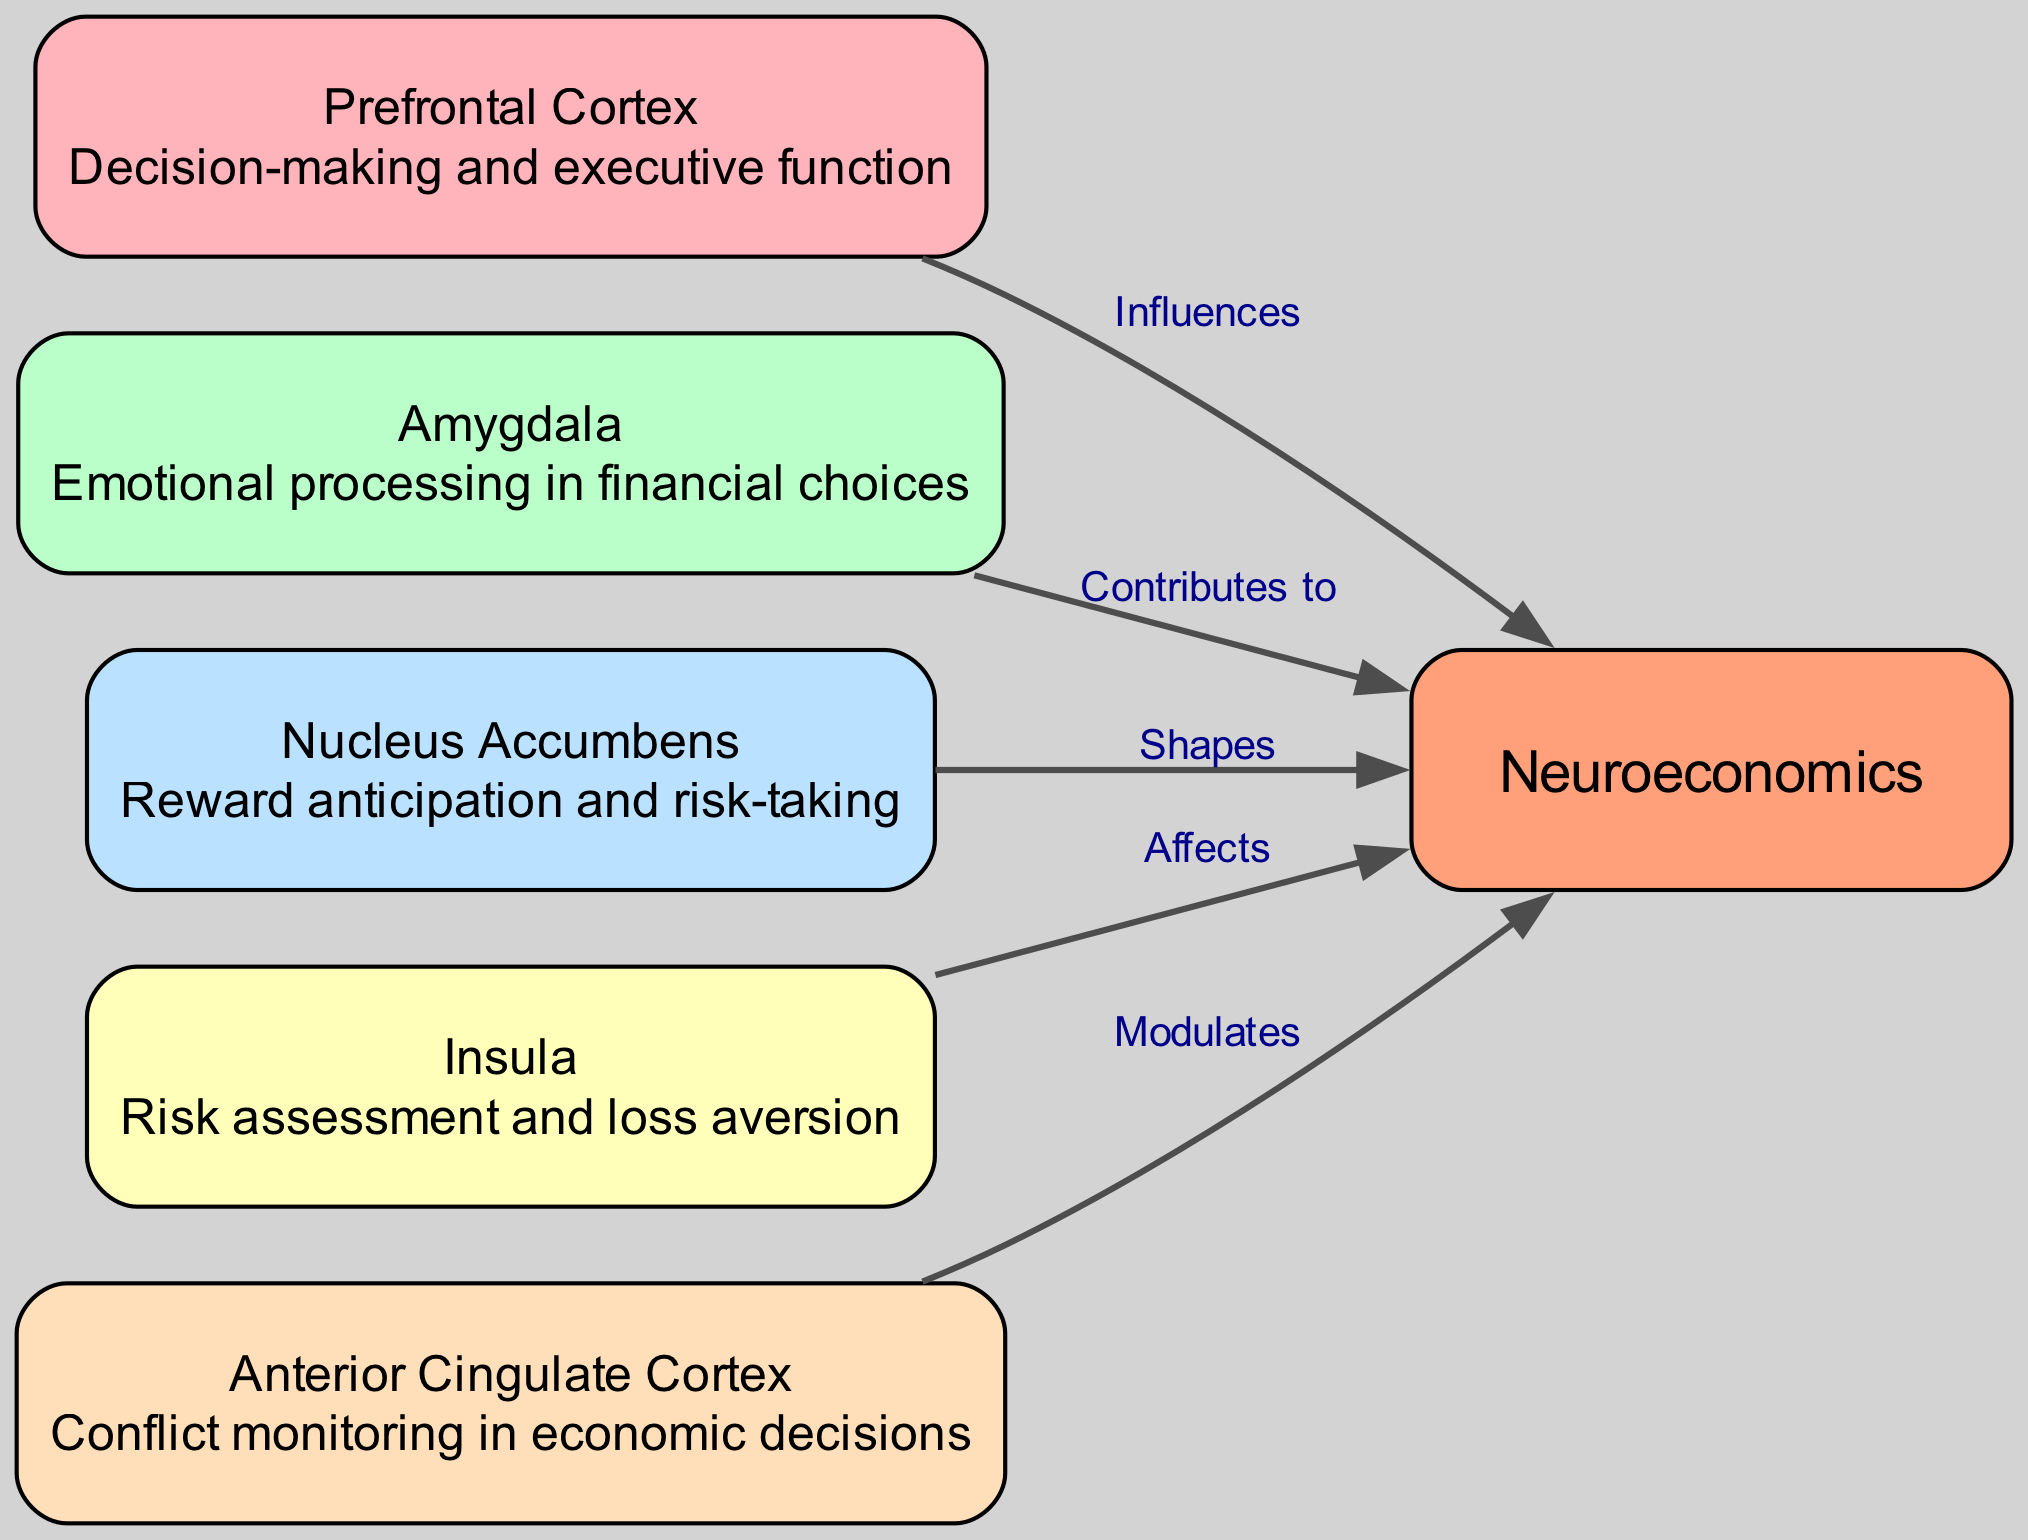What is the total number of nodes in the diagram? The diagram presents a total of 6 distinct nodes, each representing different brain regions and their roles in economic behavior.
Answer: 6 Which node is involved in decision-making and executive function? The Prefrontal Cortex is specifically identified as the region responsible for decision-making and executive functions in the diagram.
Answer: Prefrontal Cortex How many edges are connected to the Neuroeconomics node? The Neuroeconomics node has 5 edges connected to it, representing influences from various brain regions listed in the diagram.
Answer: 5 What relationship does the Nucleus Accumbens have with Neuroeconomics? The Nucleus Accumbens shapes the understanding of Neuroeconomics, suggesting its influence on reward and risk aspects of financial decision-making.
Answer: Shapes Which node contributes to emotional processing in financial choices? The Amygdala is identified as the node that contributes to emotional processing when making financial decisions in the diagram.
Answer: Amygdala What brain region is associated with risk assessment and loss aversion? The Insula is directly associated with risk assessment and loss aversion, which is essential for evaluating financial decisions in the diagram.
Answer: Insula What key function does the Anterior Cingulate Cortex serve in economic decisions? The Anterior Cingulate Cortex modulates conflict monitoring in economic decisions, indicating its role in understanding and resolving uncertainties.
Answer: Modulates How does the Prefrontal Cortex relate to Neuroeconomics? The Prefrontal Cortex influences Neuroeconomics, highlighting its crucial role in decision-making processes regarding economic behavior.
Answer: Influences Which two nodes are directly linked to the concept of Contributes to in the diagram? The nodes that are linked through the label “Contributes to” are the Amygdala and Neuroeconomics, indicating the role of emotional processing in economic behavior.
Answer: Amygdala and Neuroeconomics 